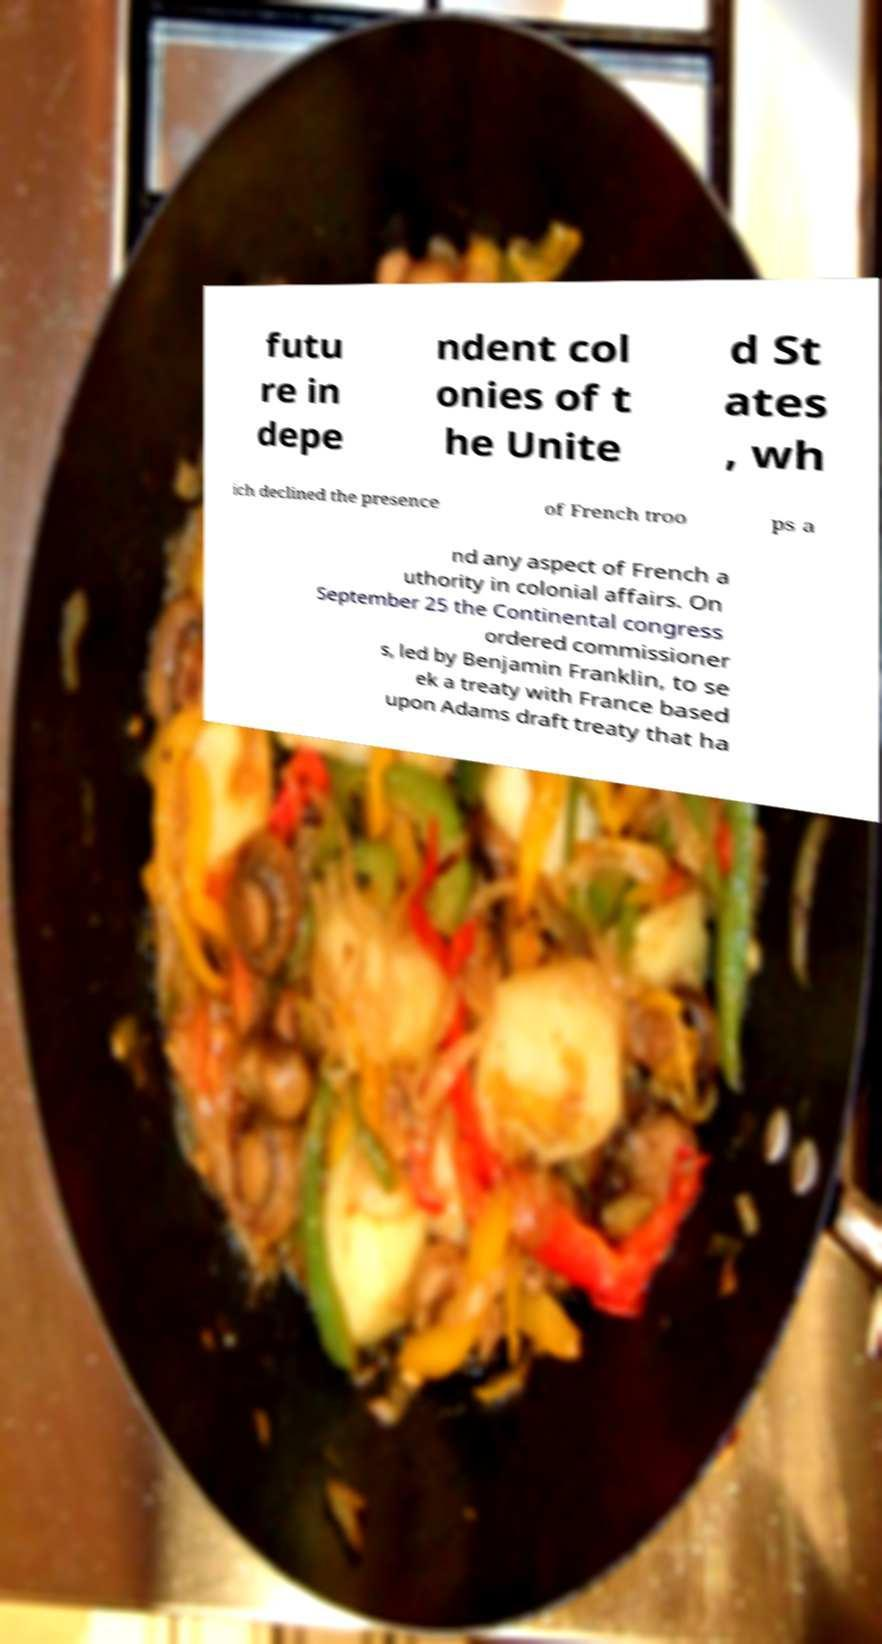For documentation purposes, I need the text within this image transcribed. Could you provide that? futu re in depe ndent col onies of t he Unite d St ates , wh ich declined the presence of French troo ps a nd any aspect of French a uthority in colonial affairs. On September 25 the Continental congress ordered commissioner s, led by Benjamin Franklin, to se ek a treaty with France based upon Adams draft treaty that ha 